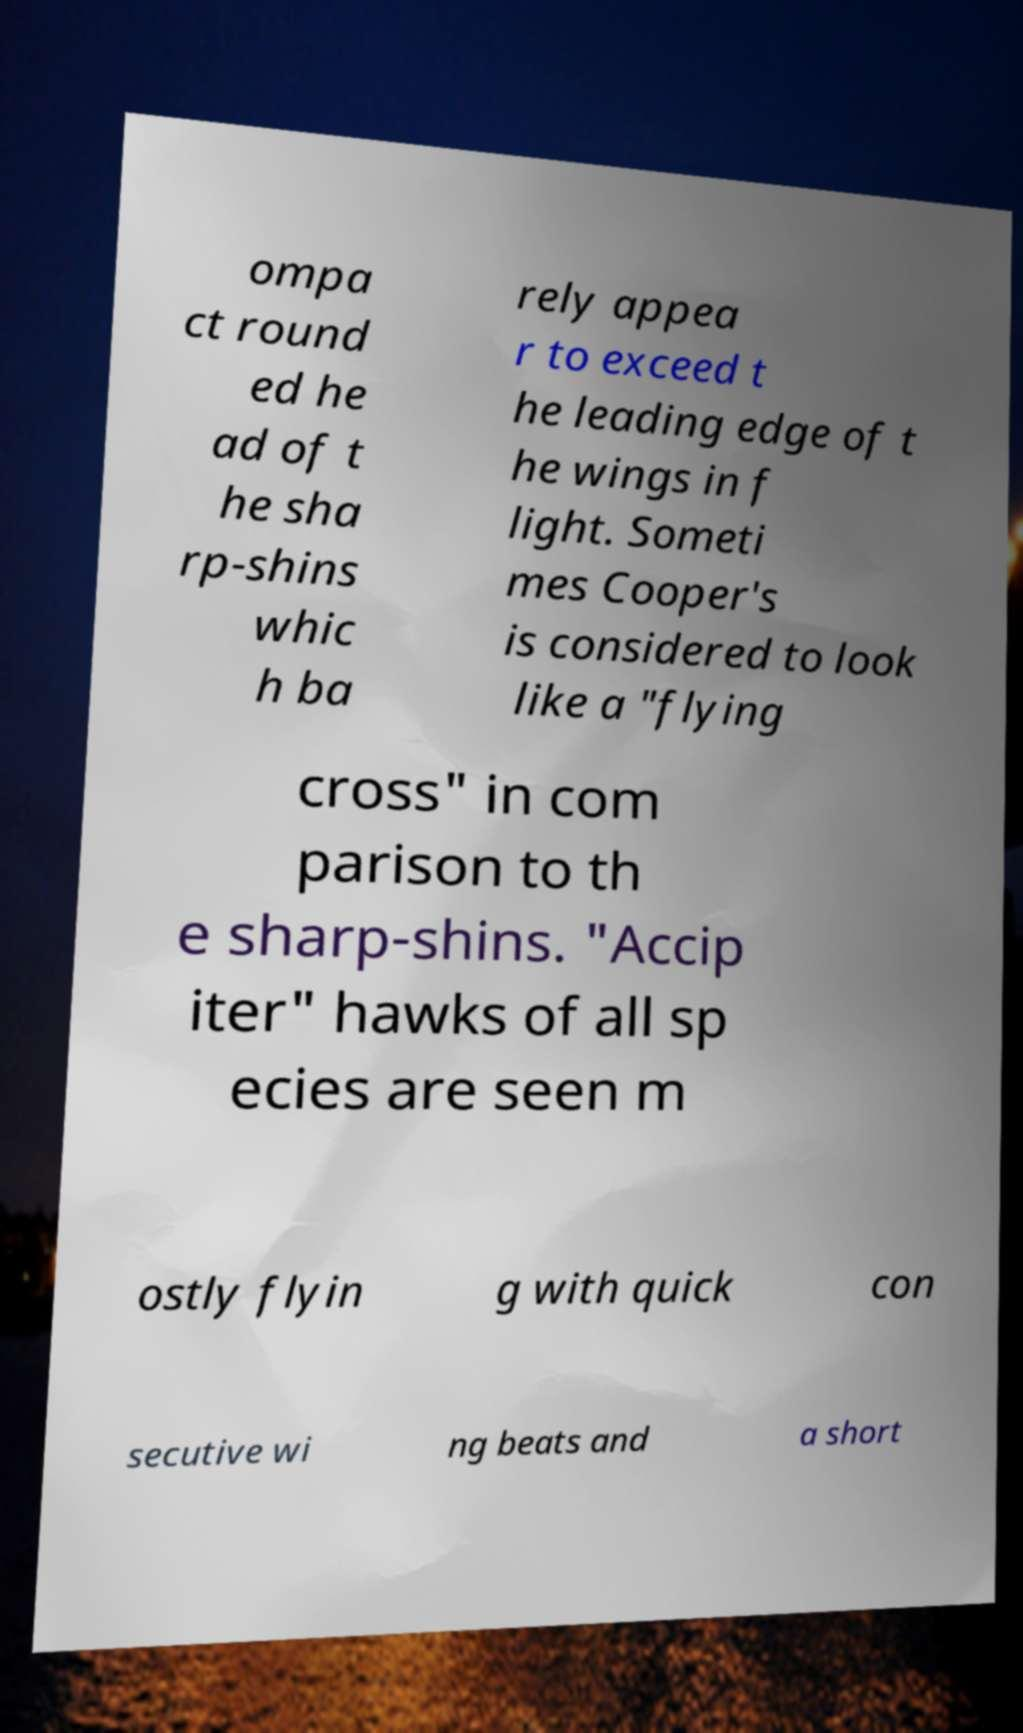Please read and relay the text visible in this image. What does it say? ompa ct round ed he ad of t he sha rp-shins whic h ba rely appea r to exceed t he leading edge of t he wings in f light. Someti mes Cooper's is considered to look like a "flying cross" in com parison to th e sharp-shins. "Accip iter" hawks of all sp ecies are seen m ostly flyin g with quick con secutive wi ng beats and a short 